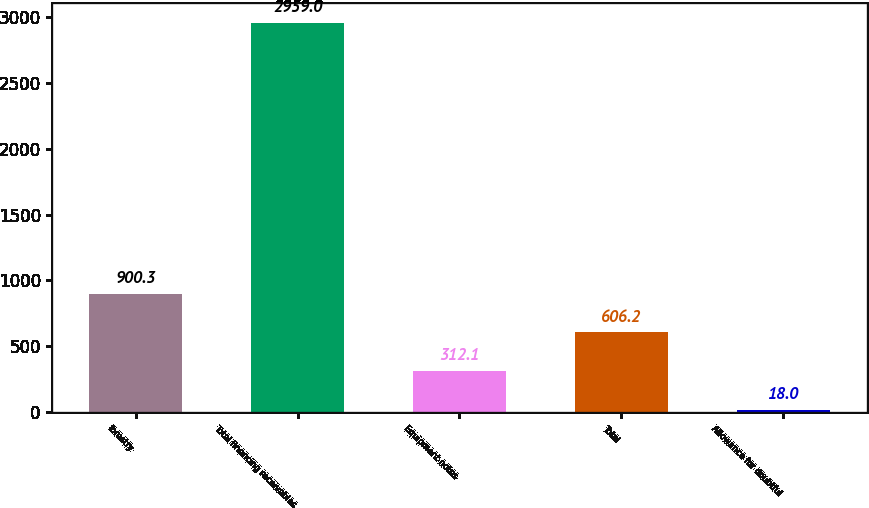<chart> <loc_0><loc_0><loc_500><loc_500><bar_chart><fcel>forestry<fcel>Total financing receivables<fcel>Equipment notes<fcel>Total<fcel>Allowance for doubtful<nl><fcel>900.3<fcel>2959<fcel>312.1<fcel>606.2<fcel>18<nl></chart> 